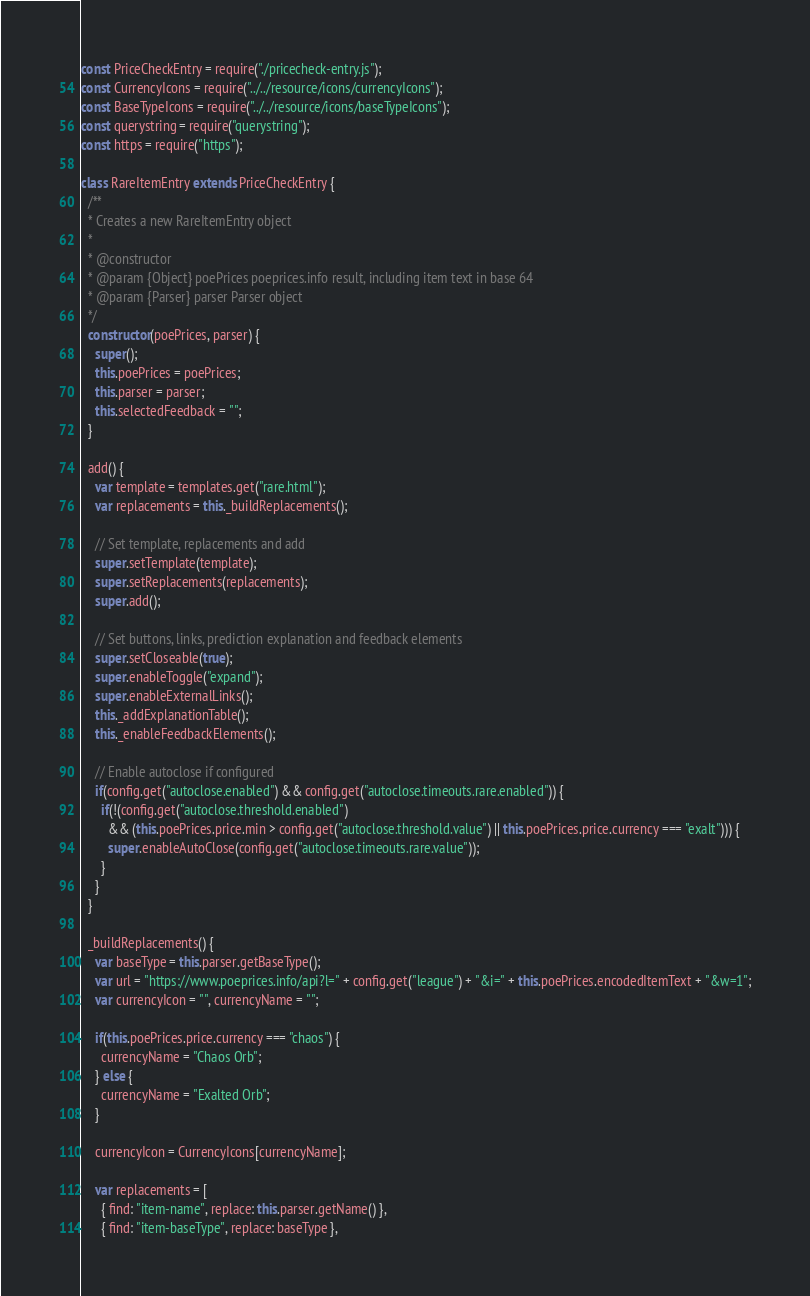<code> <loc_0><loc_0><loc_500><loc_500><_JavaScript_>const PriceCheckEntry = require("./pricecheck-entry.js");
const CurrencyIcons = require("../../resource/icons/currencyIcons");
const BaseTypeIcons = require("../../resource/icons/baseTypeIcons");
const querystring = require("querystring");
const https = require("https");

class RareItemEntry extends PriceCheckEntry {
  /**
  * Creates a new RareItemEntry object
  *
  * @constructor
  * @param {Object} poePrices poeprices.info result, including item text in base 64
  * @param {Parser} parser Parser object
  */
  constructor(poePrices, parser) {
    super();
    this.poePrices = poePrices;
    this.parser = parser;
    this.selectedFeedback = "";
  }

  add() {
    var template = templates.get("rare.html");
    var replacements = this._buildReplacements();

    // Set template, replacements and add
    super.setTemplate(template);
    super.setReplacements(replacements);
    super.add();

    // Set buttons, links, prediction explanation and feedback elements
    super.setCloseable(true);
    super.enableToggle("expand");
    super.enableExternalLinks();
    this._addExplanationTable();
    this._enableFeedbackElements();

    // Enable autoclose if configured
    if(config.get("autoclose.enabled") && config.get("autoclose.timeouts.rare.enabled")) {
      if(!(config.get("autoclose.threshold.enabled")
        && (this.poePrices.price.min > config.get("autoclose.threshold.value") || this.poePrices.price.currency === "exalt"))) {
        super.enableAutoClose(config.get("autoclose.timeouts.rare.value"));
      }
    }
  }

  _buildReplacements() {
    var baseType = this.parser.getBaseType();
    var url = "https://www.poeprices.info/api?l=" + config.get("league") + "&i=" + this.poePrices.encodedItemText + "&w=1";
    var currencyIcon = "", currencyName = "";

    if(this.poePrices.price.currency === "chaos") {
      currencyName = "Chaos Orb";
    } else {
      currencyName = "Exalted Orb";
    }

    currencyIcon = CurrencyIcons[currencyName];

    var replacements = [
      { find: "item-name", replace: this.parser.getName() },
      { find: "item-baseType", replace: baseType },</code> 